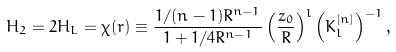<formula> <loc_0><loc_0><loc_500><loc_500>H _ { 2 } = 2 H _ { L } = \chi ( r ) \equiv \frac { 1 / ( n - 1 ) R ^ { n - 1 } } { 1 + 1 / 4 R ^ { n - 1 } } \left ( \frac { z _ { 0 } } { R } \right ) ^ { l } \left ( K _ { l } ^ { [ n ] } \right ) ^ { - 1 } ,</formula> 